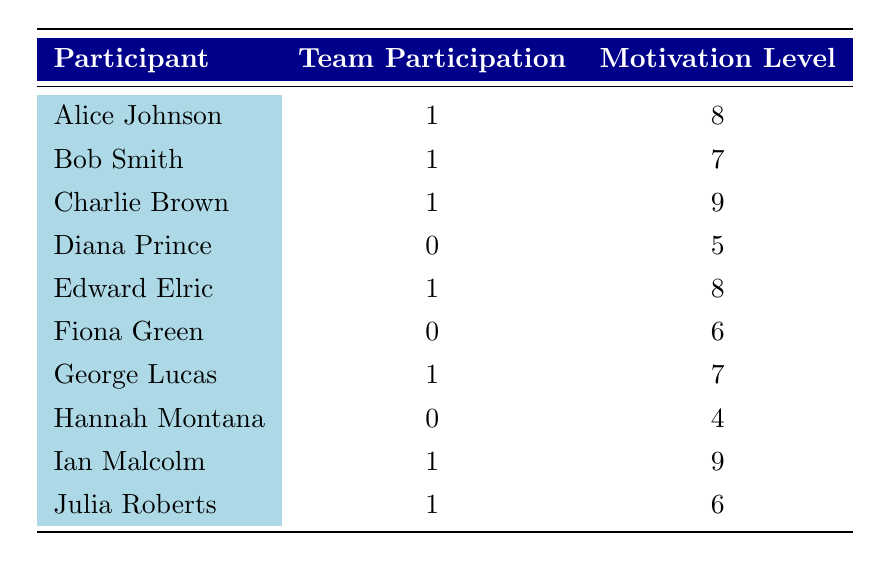What is the motivation level of Charlie Brown? Charlie Brown's motivation level is listed directly in the table as 9.
Answer: 9 How many participants have a motivation level greater than 7? The participants with motivation levels greater than 7 are Alice Johnson (8), Charlie Brown (9), Edward Elric (8), and Ian Malcolm (9). That's a total of 4 participants.
Answer: 4 What is the average motivation level of participants with team participation? The motivation levels of participants with team participation are 8, 7, 9, 8, 7, 9, and 6. Summing these gives 54, and there are 7 participants, so the average is 54/7 ≈ 7.71.
Answer: Approximately 7.71 Are there more participants with team participation than without? There are 7 participants with team participation and 3 without (Diana Prince, Fiona Green, and Hannah Montana). Since 7 is greater than 3, the answer is yes.
Answer: Yes What is the motivation level difference between the highest and lowest motivated participants? The highest motivation level is 9 (Charlie Brown or Ian Malcolm) and the lowest is 4 (Hannah Montana). The difference is 9 - 4 = 5.
Answer: 5 Which participant has the lowest motivation level, and what is that level? The participant with the lowest motivation level is Hannah Montana, with a motivation level of 4.
Answer: Hannah Montana, 4 How many participants have a motivation level of 6? The participants with a motivation level of 6 are Fiona Green and Julia Roberts, making a total of 2 participants.
Answer: 2 What is the total motivation level of all participants with team participation? The motivation levels of participants with team participation are 8, 7, 9, 8, 7, 9, and 6. Adding these up gives 54.
Answer: 54 What is the median motivation level of participants without team participation? The motivation levels of participants without team participation are 5 (Diana Prince), 6 (Fiona Green), and 4 (Hannah Montana). Arranging these in order gives 4, 5, 6. The median value (middle value) is 5.
Answer: 5 